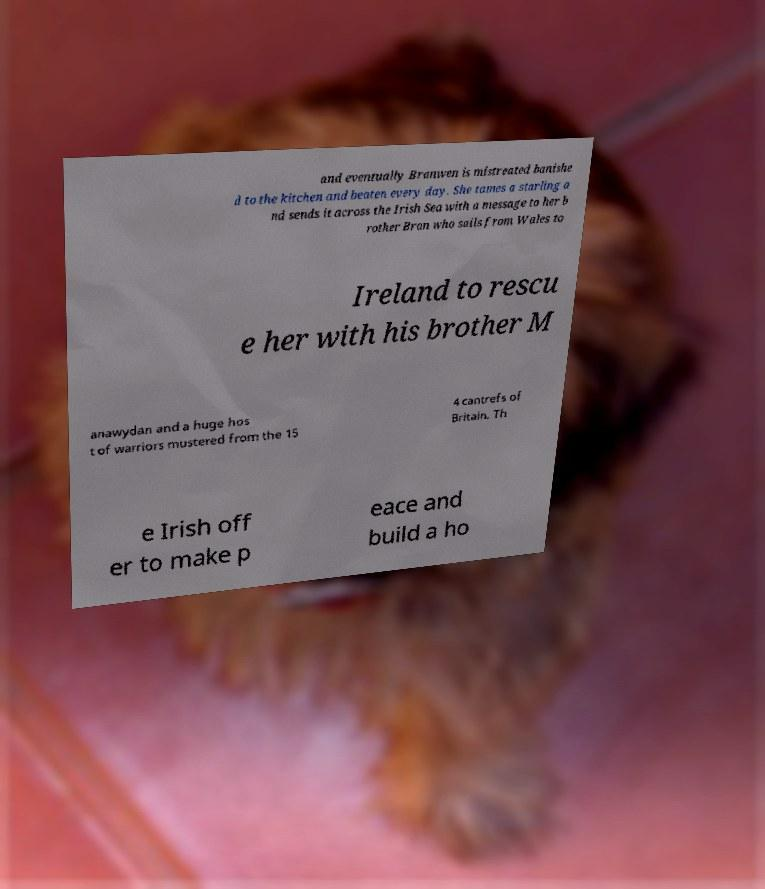Could you assist in decoding the text presented in this image and type it out clearly? and eventually Branwen is mistreated banishe d to the kitchen and beaten every day. She tames a starling a nd sends it across the Irish Sea with a message to her b rother Bran who sails from Wales to Ireland to rescu e her with his brother M anawydan and a huge hos t of warriors mustered from the 15 4 cantrefs of Britain. Th e Irish off er to make p eace and build a ho 